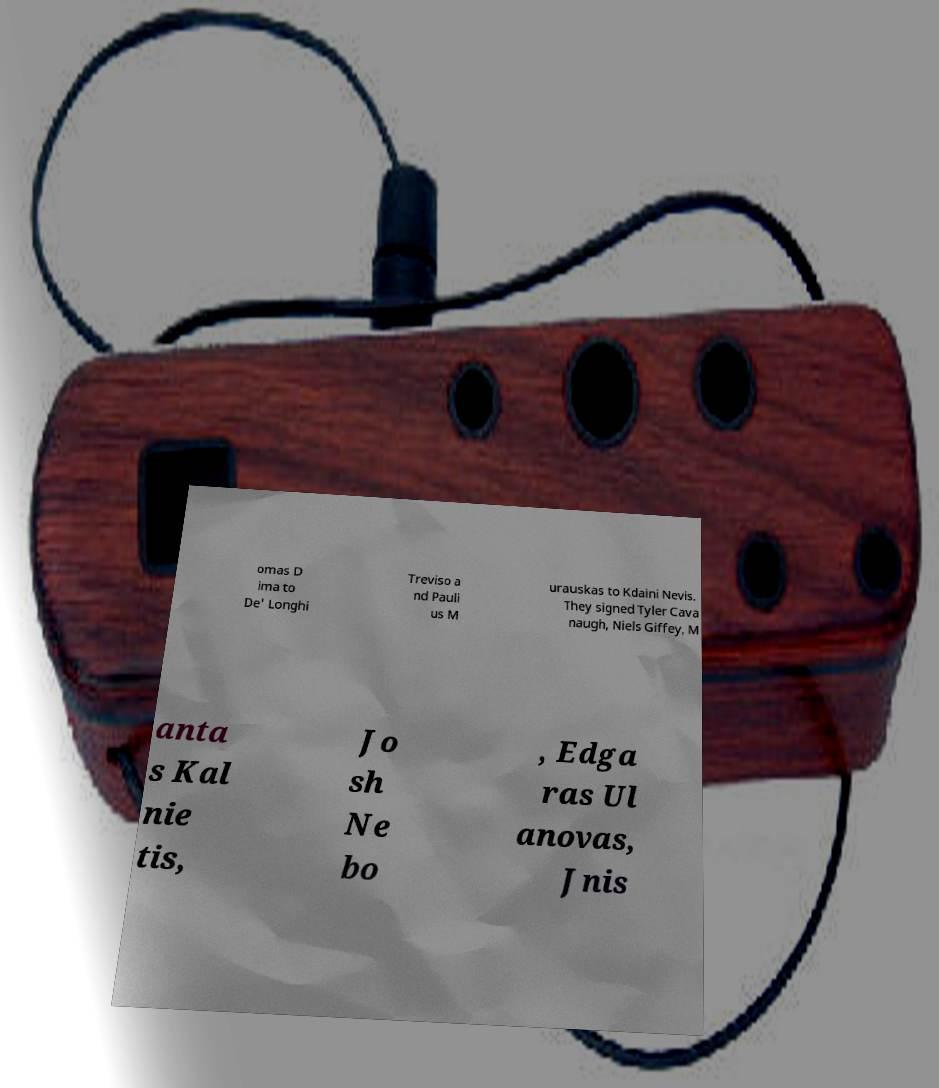Could you extract and type out the text from this image? omas D ima to De' Longhi Treviso a nd Pauli us M urauskas to Kdaini Nevis. They signed Tyler Cava naugh, Niels Giffey, M anta s Kal nie tis, Jo sh Ne bo , Edga ras Ul anovas, Jnis 